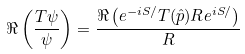Convert formula to latex. <formula><loc_0><loc_0><loc_500><loc_500>\Re \left ( \frac { T \psi } { \psi } \right ) = \frac { \Re \left ( e ^ { - i S / } T ( \hat { p } ) R e ^ { i S / } \right ) } { R }</formula> 